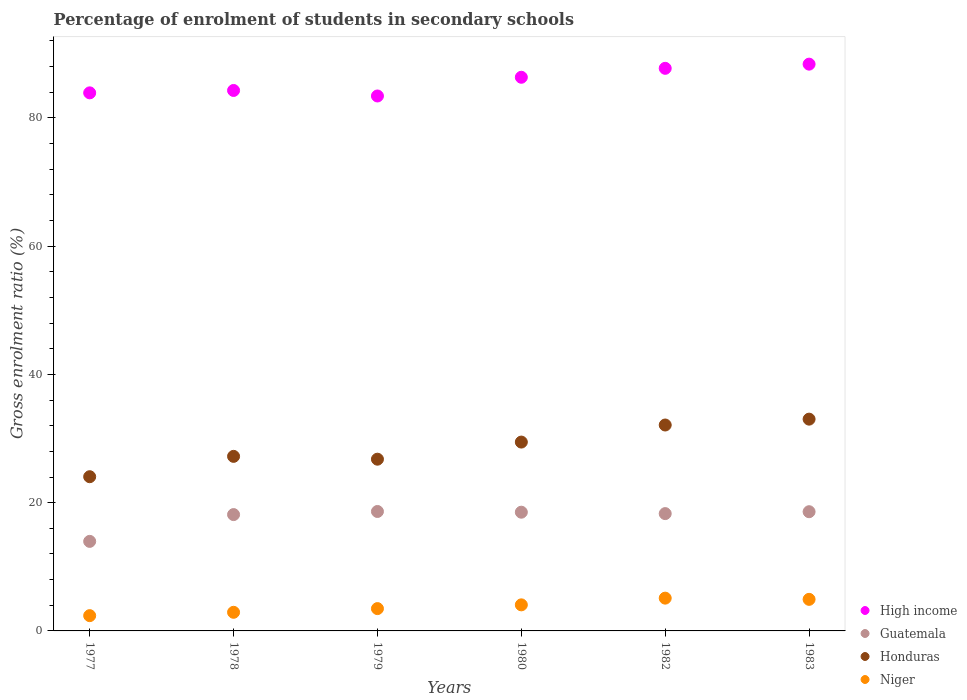How many different coloured dotlines are there?
Offer a terse response. 4. Is the number of dotlines equal to the number of legend labels?
Your response must be concise. Yes. What is the percentage of students enrolled in secondary schools in High income in 1980?
Give a very brief answer. 86.33. Across all years, what is the maximum percentage of students enrolled in secondary schools in High income?
Offer a terse response. 88.38. Across all years, what is the minimum percentage of students enrolled in secondary schools in Honduras?
Your answer should be compact. 24.05. In which year was the percentage of students enrolled in secondary schools in High income minimum?
Ensure brevity in your answer.  1979. What is the total percentage of students enrolled in secondary schools in Niger in the graph?
Provide a short and direct response. 22.86. What is the difference between the percentage of students enrolled in secondary schools in Guatemala in 1978 and that in 1983?
Your answer should be compact. -0.45. What is the difference between the percentage of students enrolled in secondary schools in Niger in 1983 and the percentage of students enrolled in secondary schools in High income in 1982?
Offer a terse response. -82.8. What is the average percentage of students enrolled in secondary schools in Honduras per year?
Keep it short and to the point. 28.77. In the year 1982, what is the difference between the percentage of students enrolled in secondary schools in Guatemala and percentage of students enrolled in secondary schools in Honduras?
Provide a succinct answer. -13.82. What is the ratio of the percentage of students enrolled in secondary schools in Niger in 1979 to that in 1982?
Make the answer very short. 0.68. Is the difference between the percentage of students enrolled in secondary schools in Guatemala in 1977 and 1978 greater than the difference between the percentage of students enrolled in secondary schools in Honduras in 1977 and 1978?
Your answer should be compact. No. What is the difference between the highest and the second highest percentage of students enrolled in secondary schools in Niger?
Provide a short and direct response. 0.19. What is the difference between the highest and the lowest percentage of students enrolled in secondary schools in Niger?
Give a very brief answer. 2.73. Is the sum of the percentage of students enrolled in secondary schools in Niger in 1977 and 1979 greater than the maximum percentage of students enrolled in secondary schools in High income across all years?
Ensure brevity in your answer.  No. Does the percentage of students enrolled in secondary schools in Niger monotonically increase over the years?
Provide a succinct answer. No. How many years are there in the graph?
Keep it short and to the point. 6. Where does the legend appear in the graph?
Make the answer very short. Bottom right. How many legend labels are there?
Provide a succinct answer. 4. What is the title of the graph?
Your response must be concise. Percentage of enrolment of students in secondary schools. Does "Least developed countries" appear as one of the legend labels in the graph?
Keep it short and to the point. No. What is the label or title of the Y-axis?
Offer a terse response. Gross enrolment ratio (%). What is the Gross enrolment ratio (%) of High income in 1977?
Offer a very short reply. 83.9. What is the Gross enrolment ratio (%) in Guatemala in 1977?
Your answer should be compact. 13.96. What is the Gross enrolment ratio (%) in Honduras in 1977?
Provide a succinct answer. 24.05. What is the Gross enrolment ratio (%) of Niger in 1977?
Offer a terse response. 2.38. What is the Gross enrolment ratio (%) in High income in 1978?
Keep it short and to the point. 84.27. What is the Gross enrolment ratio (%) of Guatemala in 1978?
Provide a succinct answer. 18.14. What is the Gross enrolment ratio (%) of Honduras in 1978?
Your answer should be compact. 27.22. What is the Gross enrolment ratio (%) of Niger in 1978?
Make the answer very short. 2.9. What is the Gross enrolment ratio (%) in High income in 1979?
Your answer should be very brief. 83.41. What is the Gross enrolment ratio (%) of Guatemala in 1979?
Offer a very short reply. 18.62. What is the Gross enrolment ratio (%) in Honduras in 1979?
Offer a very short reply. 26.78. What is the Gross enrolment ratio (%) in Niger in 1979?
Make the answer very short. 3.48. What is the Gross enrolment ratio (%) in High income in 1980?
Offer a very short reply. 86.33. What is the Gross enrolment ratio (%) in Guatemala in 1980?
Keep it short and to the point. 18.51. What is the Gross enrolment ratio (%) of Honduras in 1980?
Provide a succinct answer. 29.45. What is the Gross enrolment ratio (%) in Niger in 1980?
Give a very brief answer. 4.06. What is the Gross enrolment ratio (%) of High income in 1982?
Your answer should be compact. 87.72. What is the Gross enrolment ratio (%) of Guatemala in 1982?
Ensure brevity in your answer.  18.29. What is the Gross enrolment ratio (%) of Honduras in 1982?
Offer a terse response. 32.11. What is the Gross enrolment ratio (%) in Niger in 1982?
Your response must be concise. 5.11. What is the Gross enrolment ratio (%) of High income in 1983?
Offer a terse response. 88.38. What is the Gross enrolment ratio (%) in Guatemala in 1983?
Keep it short and to the point. 18.59. What is the Gross enrolment ratio (%) in Honduras in 1983?
Your response must be concise. 33.02. What is the Gross enrolment ratio (%) in Niger in 1983?
Provide a succinct answer. 4.92. Across all years, what is the maximum Gross enrolment ratio (%) of High income?
Your answer should be very brief. 88.38. Across all years, what is the maximum Gross enrolment ratio (%) of Guatemala?
Your response must be concise. 18.62. Across all years, what is the maximum Gross enrolment ratio (%) of Honduras?
Offer a terse response. 33.02. Across all years, what is the maximum Gross enrolment ratio (%) in Niger?
Provide a succinct answer. 5.11. Across all years, what is the minimum Gross enrolment ratio (%) in High income?
Offer a very short reply. 83.41. Across all years, what is the minimum Gross enrolment ratio (%) in Guatemala?
Provide a succinct answer. 13.96. Across all years, what is the minimum Gross enrolment ratio (%) of Honduras?
Keep it short and to the point. 24.05. Across all years, what is the minimum Gross enrolment ratio (%) in Niger?
Offer a very short reply. 2.38. What is the total Gross enrolment ratio (%) in High income in the graph?
Provide a succinct answer. 514.01. What is the total Gross enrolment ratio (%) of Guatemala in the graph?
Ensure brevity in your answer.  106.12. What is the total Gross enrolment ratio (%) of Honduras in the graph?
Keep it short and to the point. 172.62. What is the total Gross enrolment ratio (%) of Niger in the graph?
Your answer should be compact. 22.86. What is the difference between the Gross enrolment ratio (%) of High income in 1977 and that in 1978?
Your response must be concise. -0.37. What is the difference between the Gross enrolment ratio (%) of Guatemala in 1977 and that in 1978?
Your answer should be very brief. -4.18. What is the difference between the Gross enrolment ratio (%) in Honduras in 1977 and that in 1978?
Give a very brief answer. -3.17. What is the difference between the Gross enrolment ratio (%) in Niger in 1977 and that in 1978?
Provide a succinct answer. -0.52. What is the difference between the Gross enrolment ratio (%) in High income in 1977 and that in 1979?
Offer a very short reply. 0.49. What is the difference between the Gross enrolment ratio (%) in Guatemala in 1977 and that in 1979?
Provide a succinct answer. -4.66. What is the difference between the Gross enrolment ratio (%) of Honduras in 1977 and that in 1979?
Provide a succinct answer. -2.73. What is the difference between the Gross enrolment ratio (%) in Niger in 1977 and that in 1979?
Your answer should be very brief. -1.1. What is the difference between the Gross enrolment ratio (%) in High income in 1977 and that in 1980?
Offer a very short reply. -2.43. What is the difference between the Gross enrolment ratio (%) of Guatemala in 1977 and that in 1980?
Give a very brief answer. -4.55. What is the difference between the Gross enrolment ratio (%) of Honduras in 1977 and that in 1980?
Ensure brevity in your answer.  -5.4. What is the difference between the Gross enrolment ratio (%) in Niger in 1977 and that in 1980?
Make the answer very short. -1.68. What is the difference between the Gross enrolment ratio (%) in High income in 1977 and that in 1982?
Make the answer very short. -3.82. What is the difference between the Gross enrolment ratio (%) of Guatemala in 1977 and that in 1982?
Your answer should be compact. -4.33. What is the difference between the Gross enrolment ratio (%) of Honduras in 1977 and that in 1982?
Make the answer very short. -8.06. What is the difference between the Gross enrolment ratio (%) of Niger in 1977 and that in 1982?
Offer a terse response. -2.73. What is the difference between the Gross enrolment ratio (%) in High income in 1977 and that in 1983?
Give a very brief answer. -4.48. What is the difference between the Gross enrolment ratio (%) of Guatemala in 1977 and that in 1983?
Offer a terse response. -4.63. What is the difference between the Gross enrolment ratio (%) of Honduras in 1977 and that in 1983?
Your response must be concise. -8.98. What is the difference between the Gross enrolment ratio (%) of Niger in 1977 and that in 1983?
Ensure brevity in your answer.  -2.54. What is the difference between the Gross enrolment ratio (%) in High income in 1978 and that in 1979?
Keep it short and to the point. 0.86. What is the difference between the Gross enrolment ratio (%) in Guatemala in 1978 and that in 1979?
Provide a short and direct response. -0.48. What is the difference between the Gross enrolment ratio (%) of Honduras in 1978 and that in 1979?
Offer a terse response. 0.44. What is the difference between the Gross enrolment ratio (%) of Niger in 1978 and that in 1979?
Give a very brief answer. -0.58. What is the difference between the Gross enrolment ratio (%) in High income in 1978 and that in 1980?
Ensure brevity in your answer.  -2.06. What is the difference between the Gross enrolment ratio (%) in Guatemala in 1978 and that in 1980?
Keep it short and to the point. -0.37. What is the difference between the Gross enrolment ratio (%) of Honduras in 1978 and that in 1980?
Your answer should be very brief. -2.23. What is the difference between the Gross enrolment ratio (%) of Niger in 1978 and that in 1980?
Make the answer very short. -1.16. What is the difference between the Gross enrolment ratio (%) of High income in 1978 and that in 1982?
Your answer should be very brief. -3.45. What is the difference between the Gross enrolment ratio (%) of Guatemala in 1978 and that in 1982?
Your answer should be very brief. -0.15. What is the difference between the Gross enrolment ratio (%) of Honduras in 1978 and that in 1982?
Offer a terse response. -4.89. What is the difference between the Gross enrolment ratio (%) in Niger in 1978 and that in 1982?
Ensure brevity in your answer.  -2.21. What is the difference between the Gross enrolment ratio (%) in High income in 1978 and that in 1983?
Ensure brevity in your answer.  -4.1. What is the difference between the Gross enrolment ratio (%) of Guatemala in 1978 and that in 1983?
Your response must be concise. -0.45. What is the difference between the Gross enrolment ratio (%) of Honduras in 1978 and that in 1983?
Your answer should be compact. -5.8. What is the difference between the Gross enrolment ratio (%) in Niger in 1978 and that in 1983?
Make the answer very short. -2.02. What is the difference between the Gross enrolment ratio (%) of High income in 1979 and that in 1980?
Your answer should be compact. -2.92. What is the difference between the Gross enrolment ratio (%) of Guatemala in 1979 and that in 1980?
Give a very brief answer. 0.11. What is the difference between the Gross enrolment ratio (%) in Honduras in 1979 and that in 1980?
Provide a succinct answer. -2.67. What is the difference between the Gross enrolment ratio (%) of Niger in 1979 and that in 1980?
Give a very brief answer. -0.58. What is the difference between the Gross enrolment ratio (%) of High income in 1979 and that in 1982?
Make the answer very short. -4.31. What is the difference between the Gross enrolment ratio (%) in Guatemala in 1979 and that in 1982?
Keep it short and to the point. 0.33. What is the difference between the Gross enrolment ratio (%) of Honduras in 1979 and that in 1982?
Your answer should be compact. -5.33. What is the difference between the Gross enrolment ratio (%) of Niger in 1979 and that in 1982?
Provide a succinct answer. -1.63. What is the difference between the Gross enrolment ratio (%) of High income in 1979 and that in 1983?
Your answer should be very brief. -4.96. What is the difference between the Gross enrolment ratio (%) in Guatemala in 1979 and that in 1983?
Provide a succinct answer. 0.04. What is the difference between the Gross enrolment ratio (%) of Honduras in 1979 and that in 1983?
Keep it short and to the point. -6.24. What is the difference between the Gross enrolment ratio (%) of Niger in 1979 and that in 1983?
Provide a short and direct response. -1.44. What is the difference between the Gross enrolment ratio (%) in High income in 1980 and that in 1982?
Offer a terse response. -1.39. What is the difference between the Gross enrolment ratio (%) in Guatemala in 1980 and that in 1982?
Offer a terse response. 0.22. What is the difference between the Gross enrolment ratio (%) of Honduras in 1980 and that in 1982?
Provide a short and direct response. -2.66. What is the difference between the Gross enrolment ratio (%) of Niger in 1980 and that in 1982?
Ensure brevity in your answer.  -1.05. What is the difference between the Gross enrolment ratio (%) of High income in 1980 and that in 1983?
Give a very brief answer. -2.05. What is the difference between the Gross enrolment ratio (%) of Guatemala in 1980 and that in 1983?
Make the answer very short. -0.08. What is the difference between the Gross enrolment ratio (%) in Honduras in 1980 and that in 1983?
Give a very brief answer. -3.58. What is the difference between the Gross enrolment ratio (%) in Niger in 1980 and that in 1983?
Offer a very short reply. -0.86. What is the difference between the Gross enrolment ratio (%) of High income in 1982 and that in 1983?
Ensure brevity in your answer.  -0.65. What is the difference between the Gross enrolment ratio (%) of Guatemala in 1982 and that in 1983?
Your answer should be very brief. -0.3. What is the difference between the Gross enrolment ratio (%) in Honduras in 1982 and that in 1983?
Your response must be concise. -0.91. What is the difference between the Gross enrolment ratio (%) of Niger in 1982 and that in 1983?
Your answer should be compact. 0.19. What is the difference between the Gross enrolment ratio (%) of High income in 1977 and the Gross enrolment ratio (%) of Guatemala in 1978?
Ensure brevity in your answer.  65.76. What is the difference between the Gross enrolment ratio (%) of High income in 1977 and the Gross enrolment ratio (%) of Honduras in 1978?
Ensure brevity in your answer.  56.68. What is the difference between the Gross enrolment ratio (%) of High income in 1977 and the Gross enrolment ratio (%) of Niger in 1978?
Your answer should be very brief. 81. What is the difference between the Gross enrolment ratio (%) of Guatemala in 1977 and the Gross enrolment ratio (%) of Honduras in 1978?
Provide a short and direct response. -13.26. What is the difference between the Gross enrolment ratio (%) of Guatemala in 1977 and the Gross enrolment ratio (%) of Niger in 1978?
Make the answer very short. 11.06. What is the difference between the Gross enrolment ratio (%) of Honduras in 1977 and the Gross enrolment ratio (%) of Niger in 1978?
Offer a very short reply. 21.14. What is the difference between the Gross enrolment ratio (%) of High income in 1977 and the Gross enrolment ratio (%) of Guatemala in 1979?
Your response must be concise. 65.28. What is the difference between the Gross enrolment ratio (%) of High income in 1977 and the Gross enrolment ratio (%) of Honduras in 1979?
Offer a very short reply. 57.12. What is the difference between the Gross enrolment ratio (%) of High income in 1977 and the Gross enrolment ratio (%) of Niger in 1979?
Provide a short and direct response. 80.42. What is the difference between the Gross enrolment ratio (%) in Guatemala in 1977 and the Gross enrolment ratio (%) in Honduras in 1979?
Give a very brief answer. -12.82. What is the difference between the Gross enrolment ratio (%) of Guatemala in 1977 and the Gross enrolment ratio (%) of Niger in 1979?
Ensure brevity in your answer.  10.48. What is the difference between the Gross enrolment ratio (%) in Honduras in 1977 and the Gross enrolment ratio (%) in Niger in 1979?
Offer a terse response. 20.57. What is the difference between the Gross enrolment ratio (%) of High income in 1977 and the Gross enrolment ratio (%) of Guatemala in 1980?
Offer a very short reply. 65.39. What is the difference between the Gross enrolment ratio (%) in High income in 1977 and the Gross enrolment ratio (%) in Honduras in 1980?
Keep it short and to the point. 54.45. What is the difference between the Gross enrolment ratio (%) of High income in 1977 and the Gross enrolment ratio (%) of Niger in 1980?
Offer a very short reply. 79.84. What is the difference between the Gross enrolment ratio (%) of Guatemala in 1977 and the Gross enrolment ratio (%) of Honduras in 1980?
Make the answer very short. -15.48. What is the difference between the Gross enrolment ratio (%) in Guatemala in 1977 and the Gross enrolment ratio (%) in Niger in 1980?
Your answer should be compact. 9.9. What is the difference between the Gross enrolment ratio (%) of Honduras in 1977 and the Gross enrolment ratio (%) of Niger in 1980?
Your response must be concise. 19.98. What is the difference between the Gross enrolment ratio (%) in High income in 1977 and the Gross enrolment ratio (%) in Guatemala in 1982?
Offer a terse response. 65.61. What is the difference between the Gross enrolment ratio (%) of High income in 1977 and the Gross enrolment ratio (%) of Honduras in 1982?
Provide a short and direct response. 51.79. What is the difference between the Gross enrolment ratio (%) in High income in 1977 and the Gross enrolment ratio (%) in Niger in 1982?
Provide a succinct answer. 78.79. What is the difference between the Gross enrolment ratio (%) in Guatemala in 1977 and the Gross enrolment ratio (%) in Honduras in 1982?
Your answer should be very brief. -18.15. What is the difference between the Gross enrolment ratio (%) of Guatemala in 1977 and the Gross enrolment ratio (%) of Niger in 1982?
Keep it short and to the point. 8.85. What is the difference between the Gross enrolment ratio (%) in Honduras in 1977 and the Gross enrolment ratio (%) in Niger in 1982?
Provide a succinct answer. 18.94. What is the difference between the Gross enrolment ratio (%) in High income in 1977 and the Gross enrolment ratio (%) in Guatemala in 1983?
Your response must be concise. 65.31. What is the difference between the Gross enrolment ratio (%) in High income in 1977 and the Gross enrolment ratio (%) in Honduras in 1983?
Your answer should be very brief. 50.88. What is the difference between the Gross enrolment ratio (%) in High income in 1977 and the Gross enrolment ratio (%) in Niger in 1983?
Your answer should be compact. 78.98. What is the difference between the Gross enrolment ratio (%) of Guatemala in 1977 and the Gross enrolment ratio (%) of Honduras in 1983?
Your answer should be compact. -19.06. What is the difference between the Gross enrolment ratio (%) of Guatemala in 1977 and the Gross enrolment ratio (%) of Niger in 1983?
Give a very brief answer. 9.04. What is the difference between the Gross enrolment ratio (%) of Honduras in 1977 and the Gross enrolment ratio (%) of Niger in 1983?
Offer a terse response. 19.12. What is the difference between the Gross enrolment ratio (%) in High income in 1978 and the Gross enrolment ratio (%) in Guatemala in 1979?
Provide a short and direct response. 65.65. What is the difference between the Gross enrolment ratio (%) of High income in 1978 and the Gross enrolment ratio (%) of Honduras in 1979?
Make the answer very short. 57.49. What is the difference between the Gross enrolment ratio (%) in High income in 1978 and the Gross enrolment ratio (%) in Niger in 1979?
Ensure brevity in your answer.  80.79. What is the difference between the Gross enrolment ratio (%) of Guatemala in 1978 and the Gross enrolment ratio (%) of Honduras in 1979?
Provide a short and direct response. -8.64. What is the difference between the Gross enrolment ratio (%) of Guatemala in 1978 and the Gross enrolment ratio (%) of Niger in 1979?
Your response must be concise. 14.66. What is the difference between the Gross enrolment ratio (%) in Honduras in 1978 and the Gross enrolment ratio (%) in Niger in 1979?
Provide a succinct answer. 23.74. What is the difference between the Gross enrolment ratio (%) in High income in 1978 and the Gross enrolment ratio (%) in Guatemala in 1980?
Offer a very short reply. 65.76. What is the difference between the Gross enrolment ratio (%) of High income in 1978 and the Gross enrolment ratio (%) of Honduras in 1980?
Offer a very short reply. 54.83. What is the difference between the Gross enrolment ratio (%) in High income in 1978 and the Gross enrolment ratio (%) in Niger in 1980?
Offer a very short reply. 80.21. What is the difference between the Gross enrolment ratio (%) in Guatemala in 1978 and the Gross enrolment ratio (%) in Honduras in 1980?
Make the answer very short. -11.31. What is the difference between the Gross enrolment ratio (%) of Guatemala in 1978 and the Gross enrolment ratio (%) of Niger in 1980?
Your answer should be very brief. 14.07. What is the difference between the Gross enrolment ratio (%) of Honduras in 1978 and the Gross enrolment ratio (%) of Niger in 1980?
Provide a succinct answer. 23.15. What is the difference between the Gross enrolment ratio (%) in High income in 1978 and the Gross enrolment ratio (%) in Guatemala in 1982?
Ensure brevity in your answer.  65.98. What is the difference between the Gross enrolment ratio (%) of High income in 1978 and the Gross enrolment ratio (%) of Honduras in 1982?
Offer a very short reply. 52.16. What is the difference between the Gross enrolment ratio (%) in High income in 1978 and the Gross enrolment ratio (%) in Niger in 1982?
Your answer should be compact. 79.16. What is the difference between the Gross enrolment ratio (%) of Guatemala in 1978 and the Gross enrolment ratio (%) of Honduras in 1982?
Offer a very short reply. -13.97. What is the difference between the Gross enrolment ratio (%) in Guatemala in 1978 and the Gross enrolment ratio (%) in Niger in 1982?
Make the answer very short. 13.03. What is the difference between the Gross enrolment ratio (%) of Honduras in 1978 and the Gross enrolment ratio (%) of Niger in 1982?
Make the answer very short. 22.11. What is the difference between the Gross enrolment ratio (%) in High income in 1978 and the Gross enrolment ratio (%) in Guatemala in 1983?
Your answer should be compact. 65.68. What is the difference between the Gross enrolment ratio (%) of High income in 1978 and the Gross enrolment ratio (%) of Honduras in 1983?
Ensure brevity in your answer.  51.25. What is the difference between the Gross enrolment ratio (%) of High income in 1978 and the Gross enrolment ratio (%) of Niger in 1983?
Your answer should be very brief. 79.35. What is the difference between the Gross enrolment ratio (%) in Guatemala in 1978 and the Gross enrolment ratio (%) in Honduras in 1983?
Ensure brevity in your answer.  -14.88. What is the difference between the Gross enrolment ratio (%) of Guatemala in 1978 and the Gross enrolment ratio (%) of Niger in 1983?
Ensure brevity in your answer.  13.22. What is the difference between the Gross enrolment ratio (%) of Honduras in 1978 and the Gross enrolment ratio (%) of Niger in 1983?
Give a very brief answer. 22.3. What is the difference between the Gross enrolment ratio (%) in High income in 1979 and the Gross enrolment ratio (%) in Guatemala in 1980?
Make the answer very short. 64.9. What is the difference between the Gross enrolment ratio (%) in High income in 1979 and the Gross enrolment ratio (%) in Honduras in 1980?
Make the answer very short. 53.97. What is the difference between the Gross enrolment ratio (%) in High income in 1979 and the Gross enrolment ratio (%) in Niger in 1980?
Your response must be concise. 79.35. What is the difference between the Gross enrolment ratio (%) in Guatemala in 1979 and the Gross enrolment ratio (%) in Honduras in 1980?
Offer a very short reply. -10.82. What is the difference between the Gross enrolment ratio (%) in Guatemala in 1979 and the Gross enrolment ratio (%) in Niger in 1980?
Ensure brevity in your answer.  14.56. What is the difference between the Gross enrolment ratio (%) of Honduras in 1979 and the Gross enrolment ratio (%) of Niger in 1980?
Ensure brevity in your answer.  22.71. What is the difference between the Gross enrolment ratio (%) of High income in 1979 and the Gross enrolment ratio (%) of Guatemala in 1982?
Provide a short and direct response. 65.12. What is the difference between the Gross enrolment ratio (%) of High income in 1979 and the Gross enrolment ratio (%) of Honduras in 1982?
Your response must be concise. 51.3. What is the difference between the Gross enrolment ratio (%) in High income in 1979 and the Gross enrolment ratio (%) in Niger in 1982?
Make the answer very short. 78.3. What is the difference between the Gross enrolment ratio (%) of Guatemala in 1979 and the Gross enrolment ratio (%) of Honduras in 1982?
Make the answer very short. -13.48. What is the difference between the Gross enrolment ratio (%) in Guatemala in 1979 and the Gross enrolment ratio (%) in Niger in 1982?
Make the answer very short. 13.51. What is the difference between the Gross enrolment ratio (%) of Honduras in 1979 and the Gross enrolment ratio (%) of Niger in 1982?
Keep it short and to the point. 21.67. What is the difference between the Gross enrolment ratio (%) of High income in 1979 and the Gross enrolment ratio (%) of Guatemala in 1983?
Your answer should be compact. 64.82. What is the difference between the Gross enrolment ratio (%) of High income in 1979 and the Gross enrolment ratio (%) of Honduras in 1983?
Ensure brevity in your answer.  50.39. What is the difference between the Gross enrolment ratio (%) of High income in 1979 and the Gross enrolment ratio (%) of Niger in 1983?
Your response must be concise. 78.49. What is the difference between the Gross enrolment ratio (%) in Guatemala in 1979 and the Gross enrolment ratio (%) in Honduras in 1983?
Give a very brief answer. -14.4. What is the difference between the Gross enrolment ratio (%) in Guatemala in 1979 and the Gross enrolment ratio (%) in Niger in 1983?
Your answer should be very brief. 13.7. What is the difference between the Gross enrolment ratio (%) of Honduras in 1979 and the Gross enrolment ratio (%) of Niger in 1983?
Your answer should be very brief. 21.86. What is the difference between the Gross enrolment ratio (%) in High income in 1980 and the Gross enrolment ratio (%) in Guatemala in 1982?
Offer a very short reply. 68.04. What is the difference between the Gross enrolment ratio (%) in High income in 1980 and the Gross enrolment ratio (%) in Honduras in 1982?
Ensure brevity in your answer.  54.22. What is the difference between the Gross enrolment ratio (%) of High income in 1980 and the Gross enrolment ratio (%) of Niger in 1982?
Make the answer very short. 81.22. What is the difference between the Gross enrolment ratio (%) in Guatemala in 1980 and the Gross enrolment ratio (%) in Honduras in 1982?
Keep it short and to the point. -13.6. What is the difference between the Gross enrolment ratio (%) of Guatemala in 1980 and the Gross enrolment ratio (%) of Niger in 1982?
Keep it short and to the point. 13.4. What is the difference between the Gross enrolment ratio (%) of Honduras in 1980 and the Gross enrolment ratio (%) of Niger in 1982?
Your answer should be very brief. 24.34. What is the difference between the Gross enrolment ratio (%) in High income in 1980 and the Gross enrolment ratio (%) in Guatemala in 1983?
Your answer should be very brief. 67.74. What is the difference between the Gross enrolment ratio (%) in High income in 1980 and the Gross enrolment ratio (%) in Honduras in 1983?
Provide a short and direct response. 53.31. What is the difference between the Gross enrolment ratio (%) in High income in 1980 and the Gross enrolment ratio (%) in Niger in 1983?
Provide a short and direct response. 81.41. What is the difference between the Gross enrolment ratio (%) in Guatemala in 1980 and the Gross enrolment ratio (%) in Honduras in 1983?
Offer a very short reply. -14.51. What is the difference between the Gross enrolment ratio (%) of Guatemala in 1980 and the Gross enrolment ratio (%) of Niger in 1983?
Give a very brief answer. 13.59. What is the difference between the Gross enrolment ratio (%) in Honduras in 1980 and the Gross enrolment ratio (%) in Niger in 1983?
Ensure brevity in your answer.  24.52. What is the difference between the Gross enrolment ratio (%) of High income in 1982 and the Gross enrolment ratio (%) of Guatemala in 1983?
Give a very brief answer. 69.14. What is the difference between the Gross enrolment ratio (%) in High income in 1982 and the Gross enrolment ratio (%) in Honduras in 1983?
Ensure brevity in your answer.  54.7. What is the difference between the Gross enrolment ratio (%) of High income in 1982 and the Gross enrolment ratio (%) of Niger in 1983?
Your answer should be compact. 82.8. What is the difference between the Gross enrolment ratio (%) in Guatemala in 1982 and the Gross enrolment ratio (%) in Honduras in 1983?
Make the answer very short. -14.73. What is the difference between the Gross enrolment ratio (%) of Guatemala in 1982 and the Gross enrolment ratio (%) of Niger in 1983?
Give a very brief answer. 13.37. What is the difference between the Gross enrolment ratio (%) of Honduras in 1982 and the Gross enrolment ratio (%) of Niger in 1983?
Your answer should be compact. 27.19. What is the average Gross enrolment ratio (%) in High income per year?
Offer a very short reply. 85.67. What is the average Gross enrolment ratio (%) in Guatemala per year?
Provide a succinct answer. 17.69. What is the average Gross enrolment ratio (%) of Honduras per year?
Provide a succinct answer. 28.77. What is the average Gross enrolment ratio (%) in Niger per year?
Keep it short and to the point. 3.81. In the year 1977, what is the difference between the Gross enrolment ratio (%) in High income and Gross enrolment ratio (%) in Guatemala?
Your response must be concise. 69.94. In the year 1977, what is the difference between the Gross enrolment ratio (%) of High income and Gross enrolment ratio (%) of Honduras?
Give a very brief answer. 59.85. In the year 1977, what is the difference between the Gross enrolment ratio (%) of High income and Gross enrolment ratio (%) of Niger?
Offer a terse response. 81.52. In the year 1977, what is the difference between the Gross enrolment ratio (%) of Guatemala and Gross enrolment ratio (%) of Honduras?
Make the answer very short. -10.08. In the year 1977, what is the difference between the Gross enrolment ratio (%) of Guatemala and Gross enrolment ratio (%) of Niger?
Make the answer very short. 11.58. In the year 1977, what is the difference between the Gross enrolment ratio (%) in Honduras and Gross enrolment ratio (%) in Niger?
Your answer should be compact. 21.67. In the year 1978, what is the difference between the Gross enrolment ratio (%) in High income and Gross enrolment ratio (%) in Guatemala?
Your answer should be very brief. 66.13. In the year 1978, what is the difference between the Gross enrolment ratio (%) of High income and Gross enrolment ratio (%) of Honduras?
Your answer should be compact. 57.05. In the year 1978, what is the difference between the Gross enrolment ratio (%) in High income and Gross enrolment ratio (%) in Niger?
Provide a short and direct response. 81.37. In the year 1978, what is the difference between the Gross enrolment ratio (%) in Guatemala and Gross enrolment ratio (%) in Honduras?
Your answer should be compact. -9.08. In the year 1978, what is the difference between the Gross enrolment ratio (%) in Guatemala and Gross enrolment ratio (%) in Niger?
Offer a terse response. 15.24. In the year 1978, what is the difference between the Gross enrolment ratio (%) of Honduras and Gross enrolment ratio (%) of Niger?
Provide a succinct answer. 24.32. In the year 1979, what is the difference between the Gross enrolment ratio (%) in High income and Gross enrolment ratio (%) in Guatemala?
Your answer should be compact. 64.79. In the year 1979, what is the difference between the Gross enrolment ratio (%) in High income and Gross enrolment ratio (%) in Honduras?
Provide a succinct answer. 56.63. In the year 1979, what is the difference between the Gross enrolment ratio (%) in High income and Gross enrolment ratio (%) in Niger?
Your response must be concise. 79.93. In the year 1979, what is the difference between the Gross enrolment ratio (%) of Guatemala and Gross enrolment ratio (%) of Honduras?
Make the answer very short. -8.15. In the year 1979, what is the difference between the Gross enrolment ratio (%) in Guatemala and Gross enrolment ratio (%) in Niger?
Offer a terse response. 15.14. In the year 1979, what is the difference between the Gross enrolment ratio (%) of Honduras and Gross enrolment ratio (%) of Niger?
Your answer should be very brief. 23.3. In the year 1980, what is the difference between the Gross enrolment ratio (%) of High income and Gross enrolment ratio (%) of Guatemala?
Make the answer very short. 67.82. In the year 1980, what is the difference between the Gross enrolment ratio (%) in High income and Gross enrolment ratio (%) in Honduras?
Your answer should be very brief. 56.88. In the year 1980, what is the difference between the Gross enrolment ratio (%) in High income and Gross enrolment ratio (%) in Niger?
Ensure brevity in your answer.  82.27. In the year 1980, what is the difference between the Gross enrolment ratio (%) of Guatemala and Gross enrolment ratio (%) of Honduras?
Offer a very short reply. -10.93. In the year 1980, what is the difference between the Gross enrolment ratio (%) in Guatemala and Gross enrolment ratio (%) in Niger?
Provide a short and direct response. 14.45. In the year 1980, what is the difference between the Gross enrolment ratio (%) in Honduras and Gross enrolment ratio (%) in Niger?
Your answer should be very brief. 25.38. In the year 1982, what is the difference between the Gross enrolment ratio (%) in High income and Gross enrolment ratio (%) in Guatemala?
Make the answer very short. 69.43. In the year 1982, what is the difference between the Gross enrolment ratio (%) of High income and Gross enrolment ratio (%) of Honduras?
Give a very brief answer. 55.62. In the year 1982, what is the difference between the Gross enrolment ratio (%) in High income and Gross enrolment ratio (%) in Niger?
Your answer should be compact. 82.61. In the year 1982, what is the difference between the Gross enrolment ratio (%) in Guatemala and Gross enrolment ratio (%) in Honduras?
Your answer should be compact. -13.82. In the year 1982, what is the difference between the Gross enrolment ratio (%) in Guatemala and Gross enrolment ratio (%) in Niger?
Make the answer very short. 13.18. In the year 1982, what is the difference between the Gross enrolment ratio (%) of Honduras and Gross enrolment ratio (%) of Niger?
Provide a short and direct response. 27. In the year 1983, what is the difference between the Gross enrolment ratio (%) in High income and Gross enrolment ratio (%) in Guatemala?
Provide a succinct answer. 69.79. In the year 1983, what is the difference between the Gross enrolment ratio (%) of High income and Gross enrolment ratio (%) of Honduras?
Keep it short and to the point. 55.35. In the year 1983, what is the difference between the Gross enrolment ratio (%) in High income and Gross enrolment ratio (%) in Niger?
Provide a short and direct response. 83.45. In the year 1983, what is the difference between the Gross enrolment ratio (%) in Guatemala and Gross enrolment ratio (%) in Honduras?
Give a very brief answer. -14.43. In the year 1983, what is the difference between the Gross enrolment ratio (%) in Guatemala and Gross enrolment ratio (%) in Niger?
Ensure brevity in your answer.  13.67. In the year 1983, what is the difference between the Gross enrolment ratio (%) in Honduras and Gross enrolment ratio (%) in Niger?
Give a very brief answer. 28.1. What is the ratio of the Gross enrolment ratio (%) in High income in 1977 to that in 1978?
Make the answer very short. 1. What is the ratio of the Gross enrolment ratio (%) in Guatemala in 1977 to that in 1978?
Ensure brevity in your answer.  0.77. What is the ratio of the Gross enrolment ratio (%) of Honduras in 1977 to that in 1978?
Give a very brief answer. 0.88. What is the ratio of the Gross enrolment ratio (%) of Niger in 1977 to that in 1978?
Provide a succinct answer. 0.82. What is the ratio of the Gross enrolment ratio (%) of High income in 1977 to that in 1979?
Your answer should be very brief. 1.01. What is the ratio of the Gross enrolment ratio (%) of Guatemala in 1977 to that in 1979?
Ensure brevity in your answer.  0.75. What is the ratio of the Gross enrolment ratio (%) of Honduras in 1977 to that in 1979?
Keep it short and to the point. 0.9. What is the ratio of the Gross enrolment ratio (%) in Niger in 1977 to that in 1979?
Your answer should be very brief. 0.68. What is the ratio of the Gross enrolment ratio (%) in High income in 1977 to that in 1980?
Your answer should be very brief. 0.97. What is the ratio of the Gross enrolment ratio (%) in Guatemala in 1977 to that in 1980?
Your answer should be very brief. 0.75. What is the ratio of the Gross enrolment ratio (%) in Honduras in 1977 to that in 1980?
Make the answer very short. 0.82. What is the ratio of the Gross enrolment ratio (%) in Niger in 1977 to that in 1980?
Provide a short and direct response. 0.59. What is the ratio of the Gross enrolment ratio (%) in High income in 1977 to that in 1982?
Make the answer very short. 0.96. What is the ratio of the Gross enrolment ratio (%) of Guatemala in 1977 to that in 1982?
Your answer should be compact. 0.76. What is the ratio of the Gross enrolment ratio (%) of Honduras in 1977 to that in 1982?
Your response must be concise. 0.75. What is the ratio of the Gross enrolment ratio (%) in Niger in 1977 to that in 1982?
Offer a very short reply. 0.47. What is the ratio of the Gross enrolment ratio (%) of High income in 1977 to that in 1983?
Give a very brief answer. 0.95. What is the ratio of the Gross enrolment ratio (%) of Guatemala in 1977 to that in 1983?
Ensure brevity in your answer.  0.75. What is the ratio of the Gross enrolment ratio (%) in Honduras in 1977 to that in 1983?
Your answer should be very brief. 0.73. What is the ratio of the Gross enrolment ratio (%) in Niger in 1977 to that in 1983?
Make the answer very short. 0.48. What is the ratio of the Gross enrolment ratio (%) of High income in 1978 to that in 1979?
Give a very brief answer. 1.01. What is the ratio of the Gross enrolment ratio (%) in Honduras in 1978 to that in 1979?
Provide a short and direct response. 1.02. What is the ratio of the Gross enrolment ratio (%) in Niger in 1978 to that in 1979?
Offer a very short reply. 0.83. What is the ratio of the Gross enrolment ratio (%) in High income in 1978 to that in 1980?
Your answer should be compact. 0.98. What is the ratio of the Gross enrolment ratio (%) of Guatemala in 1978 to that in 1980?
Keep it short and to the point. 0.98. What is the ratio of the Gross enrolment ratio (%) of Honduras in 1978 to that in 1980?
Offer a very short reply. 0.92. What is the ratio of the Gross enrolment ratio (%) of Niger in 1978 to that in 1980?
Offer a very short reply. 0.71. What is the ratio of the Gross enrolment ratio (%) of High income in 1978 to that in 1982?
Make the answer very short. 0.96. What is the ratio of the Gross enrolment ratio (%) in Guatemala in 1978 to that in 1982?
Ensure brevity in your answer.  0.99. What is the ratio of the Gross enrolment ratio (%) of Honduras in 1978 to that in 1982?
Your answer should be compact. 0.85. What is the ratio of the Gross enrolment ratio (%) in Niger in 1978 to that in 1982?
Offer a very short reply. 0.57. What is the ratio of the Gross enrolment ratio (%) of High income in 1978 to that in 1983?
Ensure brevity in your answer.  0.95. What is the ratio of the Gross enrolment ratio (%) of Guatemala in 1978 to that in 1983?
Your answer should be compact. 0.98. What is the ratio of the Gross enrolment ratio (%) in Honduras in 1978 to that in 1983?
Provide a short and direct response. 0.82. What is the ratio of the Gross enrolment ratio (%) in Niger in 1978 to that in 1983?
Offer a very short reply. 0.59. What is the ratio of the Gross enrolment ratio (%) of High income in 1979 to that in 1980?
Provide a succinct answer. 0.97. What is the ratio of the Gross enrolment ratio (%) of Guatemala in 1979 to that in 1980?
Provide a short and direct response. 1.01. What is the ratio of the Gross enrolment ratio (%) in Honduras in 1979 to that in 1980?
Your answer should be very brief. 0.91. What is the ratio of the Gross enrolment ratio (%) in Niger in 1979 to that in 1980?
Your answer should be compact. 0.86. What is the ratio of the Gross enrolment ratio (%) in High income in 1979 to that in 1982?
Your answer should be compact. 0.95. What is the ratio of the Gross enrolment ratio (%) of Guatemala in 1979 to that in 1982?
Ensure brevity in your answer.  1.02. What is the ratio of the Gross enrolment ratio (%) of Honduras in 1979 to that in 1982?
Your response must be concise. 0.83. What is the ratio of the Gross enrolment ratio (%) in Niger in 1979 to that in 1982?
Provide a short and direct response. 0.68. What is the ratio of the Gross enrolment ratio (%) in High income in 1979 to that in 1983?
Keep it short and to the point. 0.94. What is the ratio of the Gross enrolment ratio (%) in Guatemala in 1979 to that in 1983?
Ensure brevity in your answer.  1. What is the ratio of the Gross enrolment ratio (%) in Honduras in 1979 to that in 1983?
Offer a very short reply. 0.81. What is the ratio of the Gross enrolment ratio (%) of Niger in 1979 to that in 1983?
Offer a terse response. 0.71. What is the ratio of the Gross enrolment ratio (%) of High income in 1980 to that in 1982?
Keep it short and to the point. 0.98. What is the ratio of the Gross enrolment ratio (%) of Guatemala in 1980 to that in 1982?
Ensure brevity in your answer.  1.01. What is the ratio of the Gross enrolment ratio (%) in Honduras in 1980 to that in 1982?
Your answer should be compact. 0.92. What is the ratio of the Gross enrolment ratio (%) in Niger in 1980 to that in 1982?
Your answer should be very brief. 0.8. What is the ratio of the Gross enrolment ratio (%) of High income in 1980 to that in 1983?
Provide a succinct answer. 0.98. What is the ratio of the Gross enrolment ratio (%) of Guatemala in 1980 to that in 1983?
Provide a succinct answer. 1. What is the ratio of the Gross enrolment ratio (%) in Honduras in 1980 to that in 1983?
Make the answer very short. 0.89. What is the ratio of the Gross enrolment ratio (%) of Niger in 1980 to that in 1983?
Ensure brevity in your answer.  0.83. What is the ratio of the Gross enrolment ratio (%) in Guatemala in 1982 to that in 1983?
Keep it short and to the point. 0.98. What is the ratio of the Gross enrolment ratio (%) of Honduras in 1982 to that in 1983?
Provide a succinct answer. 0.97. What is the ratio of the Gross enrolment ratio (%) in Niger in 1982 to that in 1983?
Offer a very short reply. 1.04. What is the difference between the highest and the second highest Gross enrolment ratio (%) in High income?
Give a very brief answer. 0.65. What is the difference between the highest and the second highest Gross enrolment ratio (%) in Guatemala?
Provide a short and direct response. 0.04. What is the difference between the highest and the second highest Gross enrolment ratio (%) in Honduras?
Make the answer very short. 0.91. What is the difference between the highest and the second highest Gross enrolment ratio (%) in Niger?
Your answer should be compact. 0.19. What is the difference between the highest and the lowest Gross enrolment ratio (%) of High income?
Provide a short and direct response. 4.96. What is the difference between the highest and the lowest Gross enrolment ratio (%) of Guatemala?
Ensure brevity in your answer.  4.66. What is the difference between the highest and the lowest Gross enrolment ratio (%) of Honduras?
Provide a short and direct response. 8.98. What is the difference between the highest and the lowest Gross enrolment ratio (%) in Niger?
Your answer should be very brief. 2.73. 